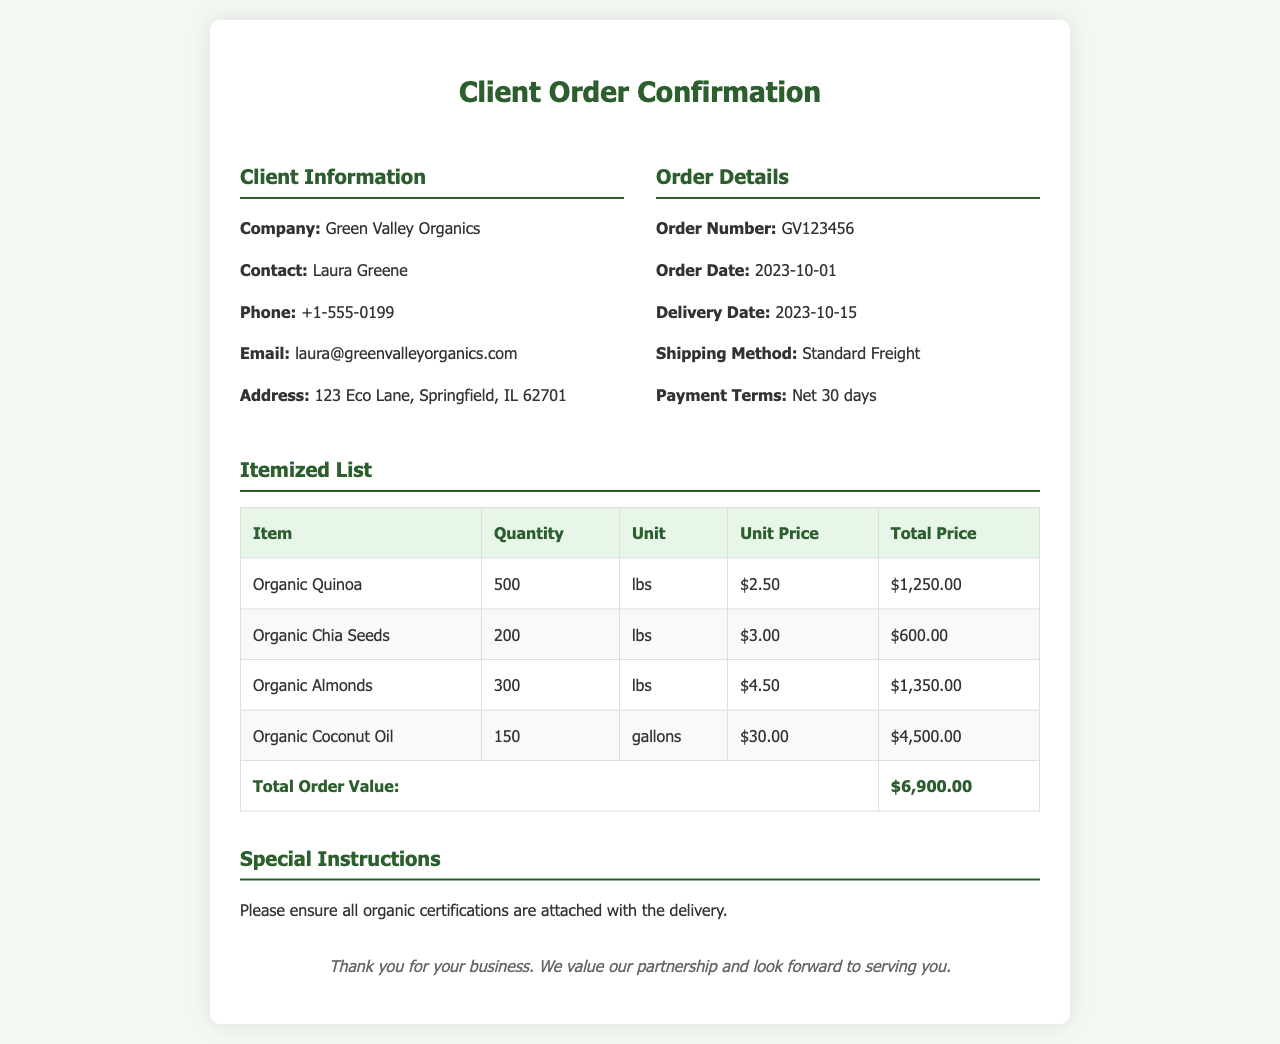What is the order number? The order number is specified in the order details section of the document.
Answer: GV123456 What is the total order value? The total order value is calculated based on the itemized prices listed in the table.
Answer: $6,900.00 When is the delivery date? The delivery date is clearly mentioned in the order details section.
Answer: 2023-10-15 Who is the contact person for the client? The contact person is mentioned under the client information section of the document.
Answer: Laura Greene How many pounds of Organic Chia Seeds were ordered? The quantity of Organic Chia Seeds is specified in the itemized list.
Answer: 200 What is the unit price of Organic Almonds? The unit price for Organic Almonds can be found in the itemized list section.
Answer: $4.50 What shipping method is used for this order? The shipping method is outlined in the order details section of the document.
Answer: Standard Freight What special instruction is provided with the order? The special instructions provide details related to the order's delivery expectations.
Answer: Please ensure all organic certifications are attached with the delivery 